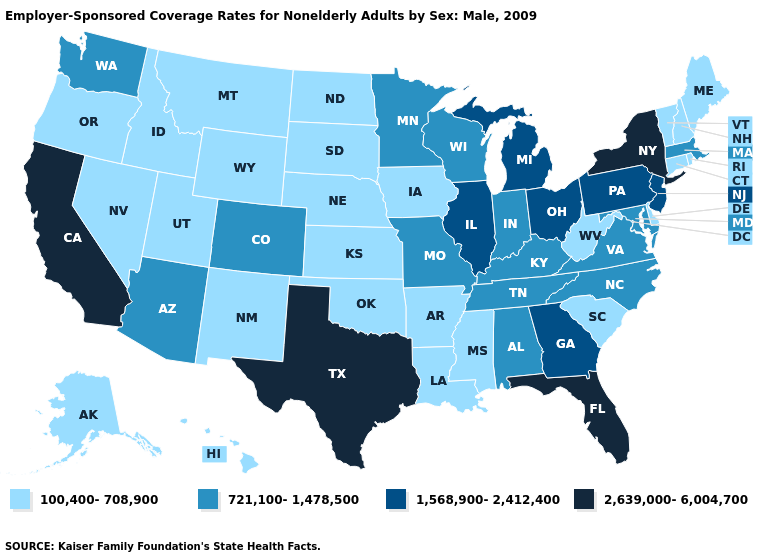What is the highest value in states that border Tennessee?
Give a very brief answer. 1,568,900-2,412,400. Name the states that have a value in the range 2,639,000-6,004,700?
Concise answer only. California, Florida, New York, Texas. Does Virginia have a lower value than Georgia?
Quick response, please. Yes. What is the lowest value in the West?
Answer briefly. 100,400-708,900. What is the value of Connecticut?
Be succinct. 100,400-708,900. Does the first symbol in the legend represent the smallest category?
Write a very short answer. Yes. Among the states that border Tennessee , which have the highest value?
Give a very brief answer. Georgia. Which states have the highest value in the USA?
Quick response, please. California, Florida, New York, Texas. Is the legend a continuous bar?
Be succinct. No. Name the states that have a value in the range 100,400-708,900?
Short answer required. Alaska, Arkansas, Connecticut, Delaware, Hawaii, Idaho, Iowa, Kansas, Louisiana, Maine, Mississippi, Montana, Nebraska, Nevada, New Hampshire, New Mexico, North Dakota, Oklahoma, Oregon, Rhode Island, South Carolina, South Dakota, Utah, Vermont, West Virginia, Wyoming. Does the map have missing data?
Concise answer only. No. What is the value of West Virginia?
Answer briefly. 100,400-708,900. Which states have the highest value in the USA?
Concise answer only. California, Florida, New York, Texas. What is the highest value in states that border Iowa?
Quick response, please. 1,568,900-2,412,400. 